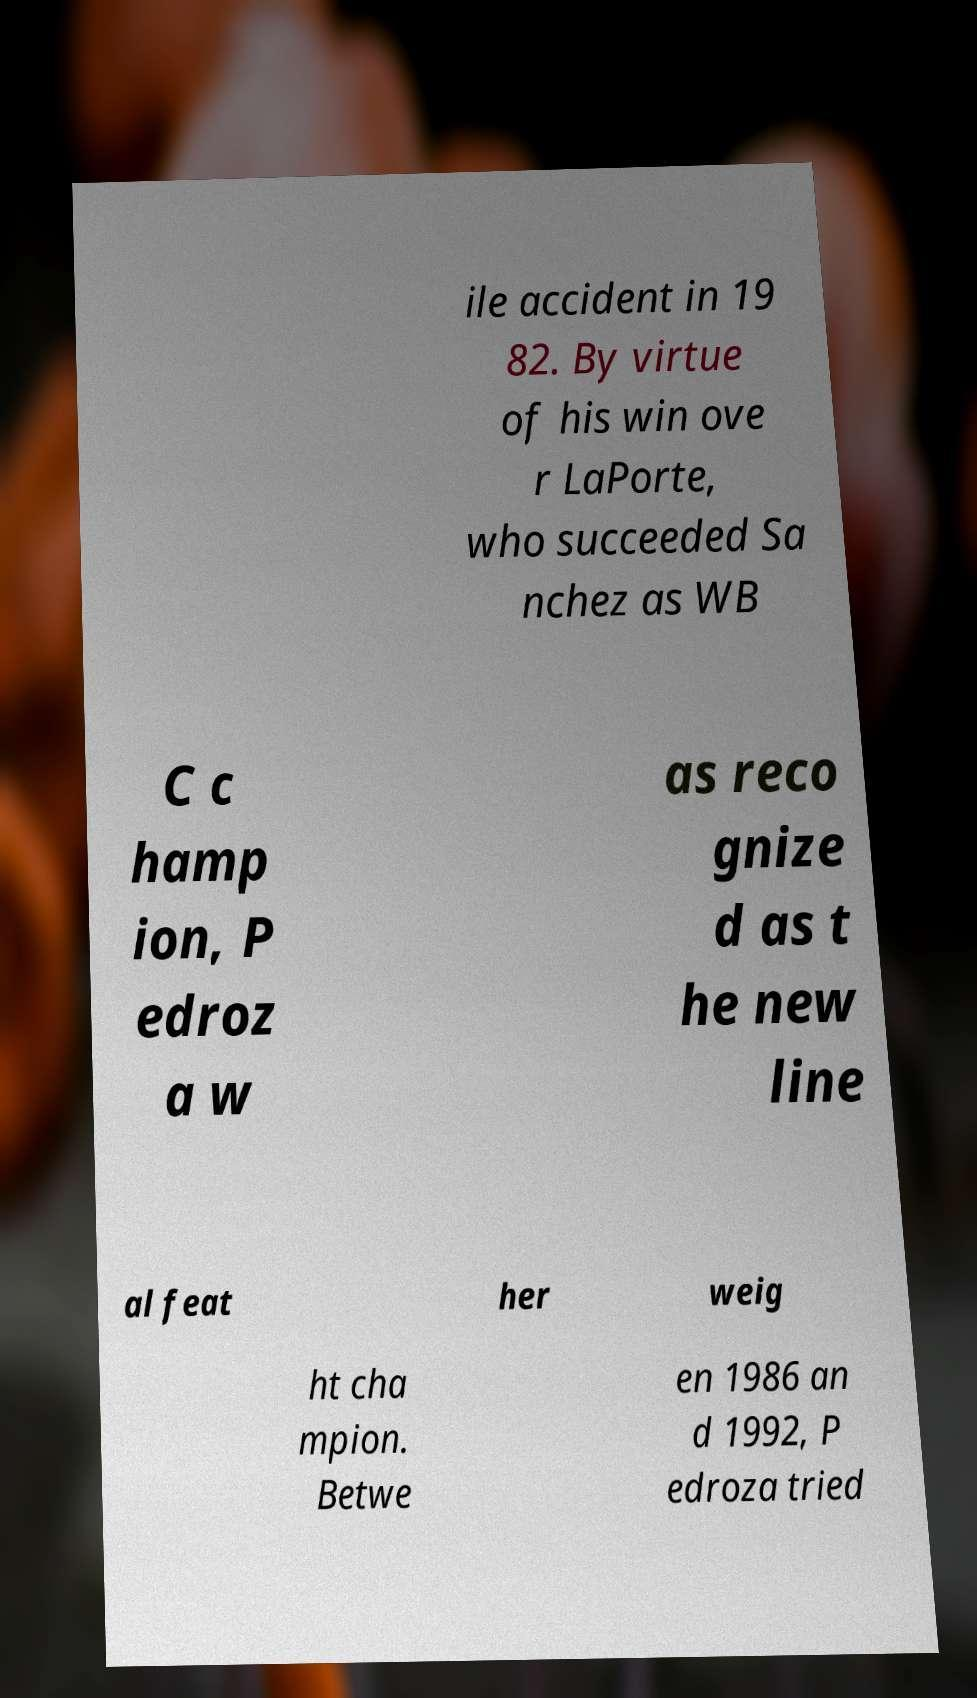What messages or text are displayed in this image? I need them in a readable, typed format. ile accident in 19 82. By virtue of his win ove r LaPorte, who succeeded Sa nchez as WB C c hamp ion, P edroz a w as reco gnize d as t he new line al feat her weig ht cha mpion. Betwe en 1986 an d 1992, P edroza tried 